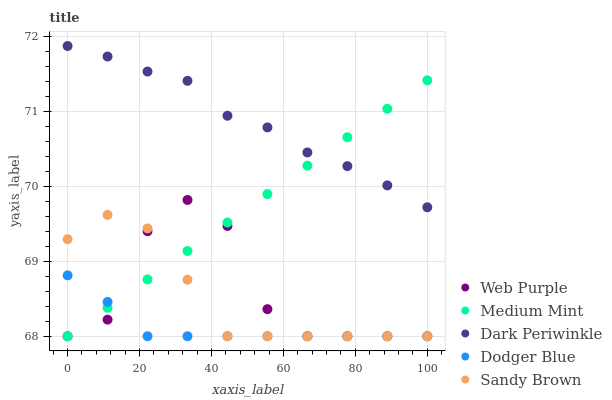Does Dodger Blue have the minimum area under the curve?
Answer yes or no. Yes. Does Dark Periwinkle have the maximum area under the curve?
Answer yes or no. Yes. Does Sandy Brown have the minimum area under the curve?
Answer yes or no. No. Does Sandy Brown have the maximum area under the curve?
Answer yes or no. No. Is Medium Mint the smoothest?
Answer yes or no. Yes. Is Web Purple the roughest?
Answer yes or no. Yes. Is Sandy Brown the smoothest?
Answer yes or no. No. Is Sandy Brown the roughest?
Answer yes or no. No. Does Medium Mint have the lowest value?
Answer yes or no. Yes. Does Dark Periwinkle have the lowest value?
Answer yes or no. No. Does Dark Periwinkle have the highest value?
Answer yes or no. Yes. Does Sandy Brown have the highest value?
Answer yes or no. No. Is Sandy Brown less than Dark Periwinkle?
Answer yes or no. Yes. Is Dark Periwinkle greater than Dodger Blue?
Answer yes or no. Yes. Does Medium Mint intersect Web Purple?
Answer yes or no. Yes. Is Medium Mint less than Web Purple?
Answer yes or no. No. Is Medium Mint greater than Web Purple?
Answer yes or no. No. Does Sandy Brown intersect Dark Periwinkle?
Answer yes or no. No. 